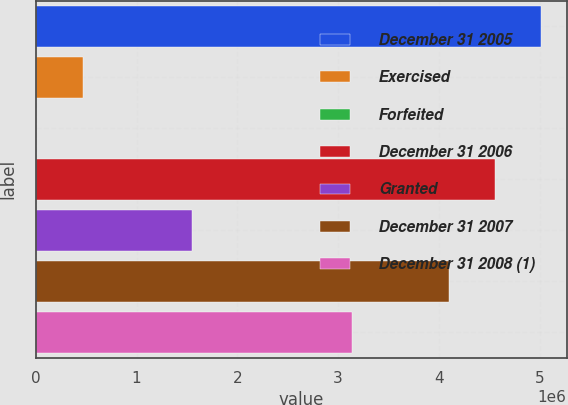Convert chart. <chart><loc_0><loc_0><loc_500><loc_500><bar_chart><fcel>December 31 2005<fcel>Exercised<fcel>Forfeited<fcel>December 31 2006<fcel>Granted<fcel>December 31 2007<fcel>December 31 2008 (1)<nl><fcel>5.01541e+06<fcel>463524<fcel>6400<fcel>4.55829e+06<fcel>1.54574e+06<fcel>4.10116e+06<fcel>3.14052e+06<nl></chart> 